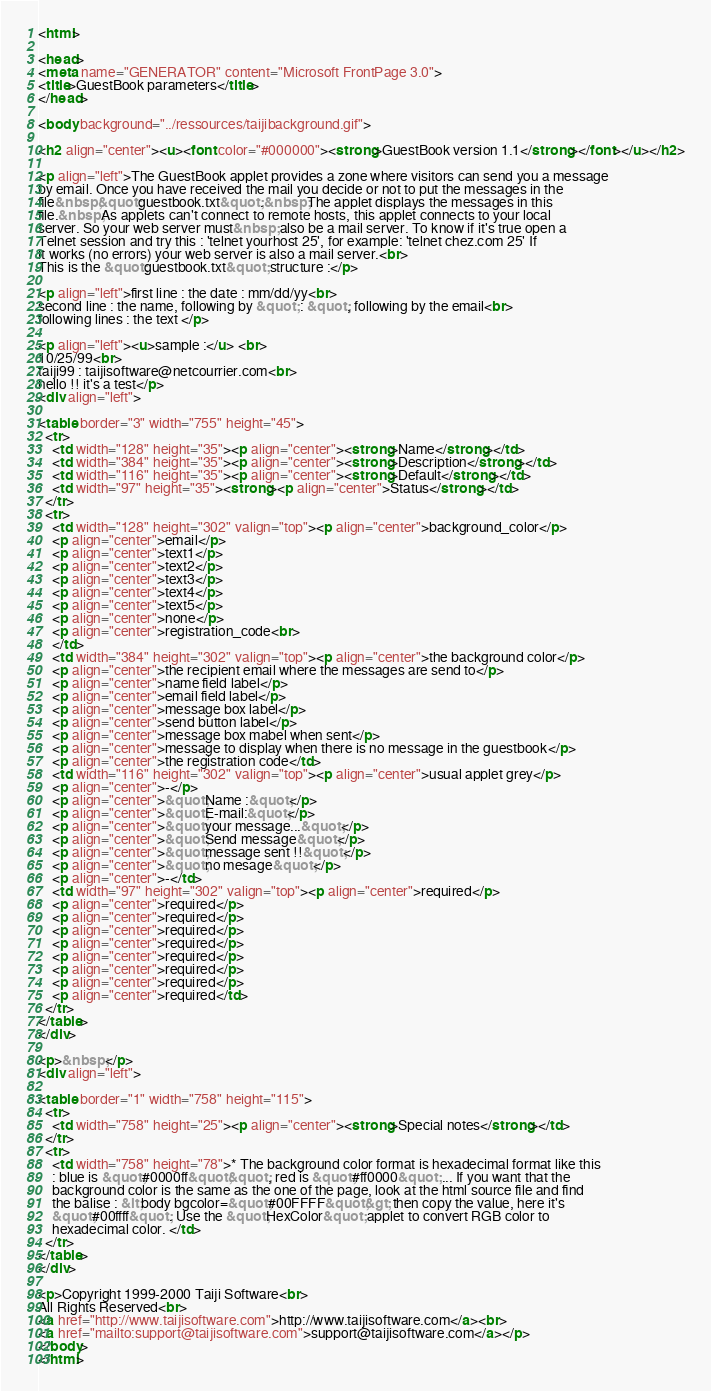<code> <loc_0><loc_0><loc_500><loc_500><_HTML_><html>

<head>
<meta name="GENERATOR" content="Microsoft FrontPage 3.0">
<title>GuestBook parameters</title>
</head>

<body background="../ressources/taijibackground.gif">

<h2 align="center"><u><font color="#000000"><strong>GuestBook version 1.1</strong></font></u></h2>

<p align="left">The GuestBook applet provides a zone where visitors can send you a message
by email. Once you have received the mail you decide or not to put the messages in the
file&nbsp;&quot;guestbook.txt&quot;.&nbsp;The applet displays the messages in this
file.&nbsp;As applets can't connect to remote hosts, this applet connects to your local
server. So your web server must&nbsp; also be a mail server. To know if it's true open a
Telnet session and try this : 'telnet yourhost 25', for example: 'telnet chez.com 25' If
it works (no errors) your web server is also a mail server.<br>
This is the &quot;guestbook.txt&quot; structure :</p>

<p align="left">first line : the date : mm/dd/yy<br>
second line : the name, following by &quot; : &quot;, following by the email<br>
following lines : the text </p>

<p align="left"><u>sample :</u> <br>
10/25/99<br>
taiji99 : taijisoftware@netcourrier.com<br>
hello !! it's a test</p>
<div align="left">

<table border="3" width="755" height="45">
  <tr>
    <td width="128" height="35"><p align="center"><strong>Name</strong></td>
    <td width="384" height="35"><p align="center"><strong>Description</strong></td>
    <td width="116" height="35"><p align="center"><strong>Default</strong></td>
    <td width="97" height="35"><strong><p align="center">Status</strong></td>
  </tr>
  <tr>
    <td width="128" height="302" valign="top"><p align="center">background_color</p>
    <p align="center">email</p>
    <p align="center">text1</p>
    <p align="center">text2</p>
    <p align="center">text3</p>
    <p align="center">text4</p>
    <p align="center">text5</p>
    <p align="center">none</p>
    <p align="center">registration_code<br>
    </td>
    <td width="384" height="302" valign="top"><p align="center">the background color</p>
    <p align="center">the recipient email where the messages are send to</p>
    <p align="center">name field label</p>
    <p align="center">email field label</p>
    <p align="center">message box label</p>
    <p align="center">send button label</p>
    <p align="center">message box mabel when sent</p>
    <p align="center">message to display when there is no message in the guestbook</p>
    <p align="center">the registration code</td>
    <td width="116" height="302" valign="top"><p align="center">usual applet grey</p>
    <p align="center">-</p>
    <p align="center">&quot;Name :&quot;</p>
    <p align="center">&quot;E-mail:&quot;</p>
    <p align="center">&quot;your message...&quot;</p>
    <p align="center">&quot;Send message&quot;</p>
    <p align="center">&quot;message sent !!&quot;</p>
    <p align="center">&quot;no mesage&quot;</p>
    <p align="center">-</td>
    <td width="97" height="302" valign="top"><p align="center">required</p>
    <p align="center">required</p>
    <p align="center">required</p>
    <p align="center">required</p>
    <p align="center">required</p>
    <p align="center">required</p>
    <p align="center">required</p>
    <p align="center">required</p>
    <p align="center">required</td>
  </tr>
</table>
</div>

<p>&nbsp;</p>
<div align="left">

<table border="1" width="758" height="115">
  <tr>
    <td width="758" height="25"><p align="center"><strong>Special notes</strong></td>
  </tr>
  <tr>
    <td width="758" height="78">* The background color format is hexadecimal format like this
    : blue is &quot;#0000ff&quot;&quot;, red is &quot;#ff0000&quot; ... If you want that the
    background color is the same as the one of the page, look at the html source file and find
    the balise : &lt;body bgcolor=&quot;#00FFFF&quot;&gt; then copy the value, here it's
    &quot;#00ffff&quot;. Use the &quot;HexColor&quot; applet to convert RGB color to
    hexadecimal color. </td>
  </tr>
</table>
</div>

<p>Copyright 1999-2000 Taiji Software<br>
All Rights Reserved<br>
<a href="http://www.taijisoftware.com">http://www.taijisoftware.com</a><br>
<a href="mailto:support@taijisoftware.com">support@taijisoftware.com</a></p>
</body>
</html>
</code> 